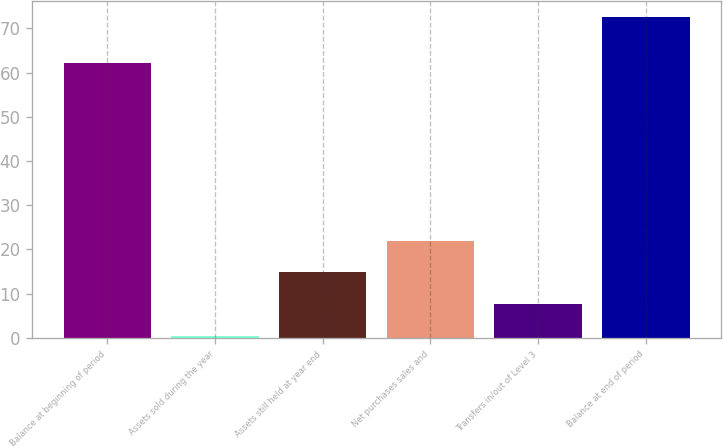Convert chart to OTSL. <chart><loc_0><loc_0><loc_500><loc_500><bar_chart><fcel>Balance at beginning of period<fcel>Assets sold during the year<fcel>Assets still held at year end<fcel>Net purchases sales and<fcel>Transfers in/out of Level 3<fcel>Balance at end of period<nl><fcel>62.1<fcel>0.4<fcel>14.82<fcel>22.03<fcel>7.61<fcel>72.5<nl></chart> 